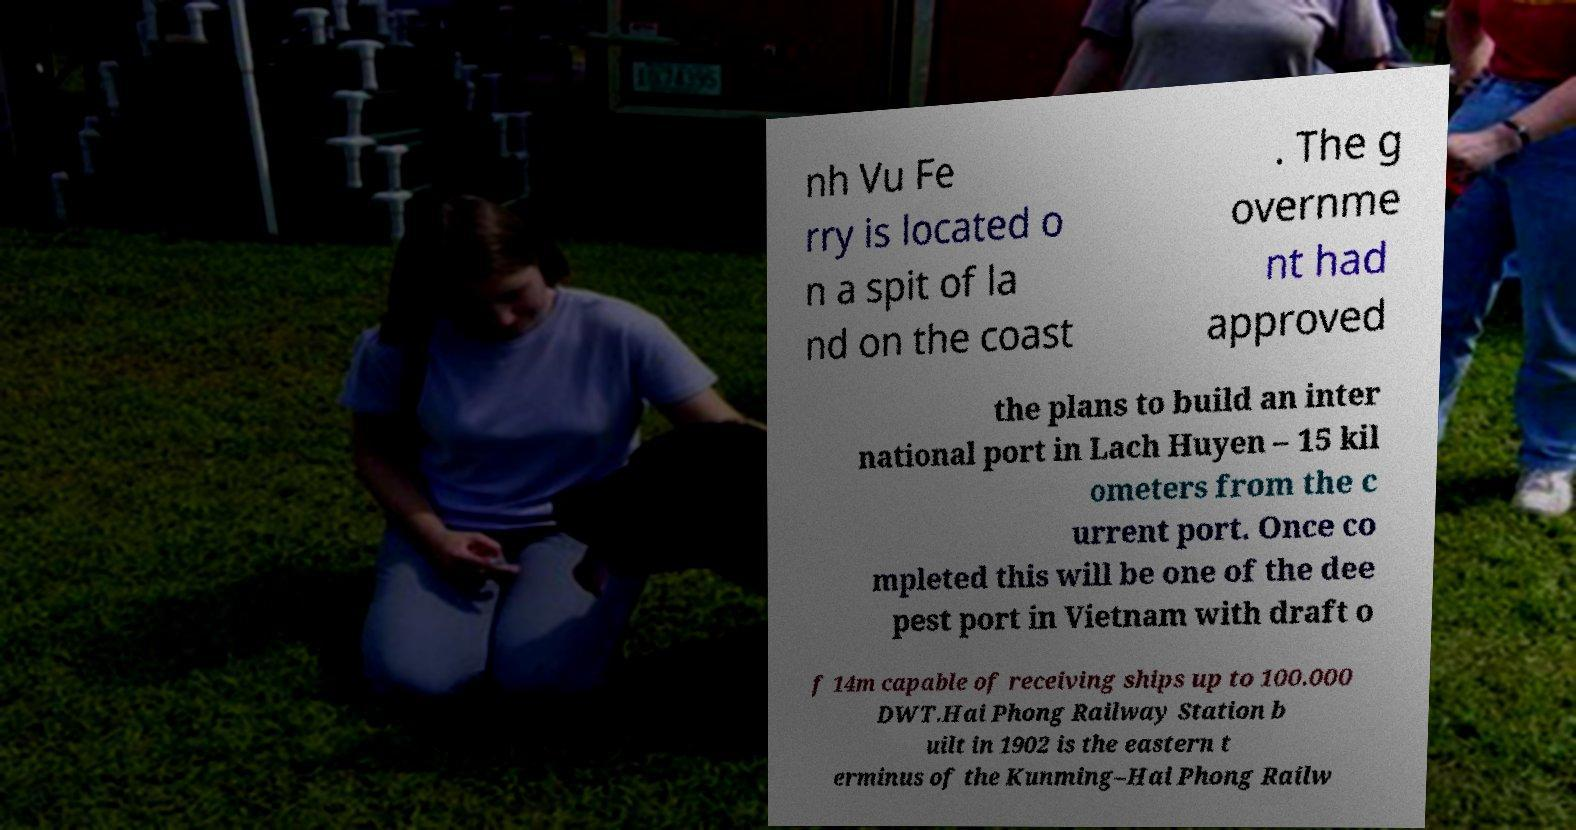For documentation purposes, I need the text within this image transcribed. Could you provide that? nh Vu Fe rry is located o n a spit of la nd on the coast . The g overnme nt had approved the plans to build an inter national port in Lach Huyen – 15 kil ometers from the c urrent port. Once co mpleted this will be one of the dee pest port in Vietnam with draft o f 14m capable of receiving ships up to 100.000 DWT.Hai Phong Railway Station b uilt in 1902 is the eastern t erminus of the Kunming–Hai Phong Railw 